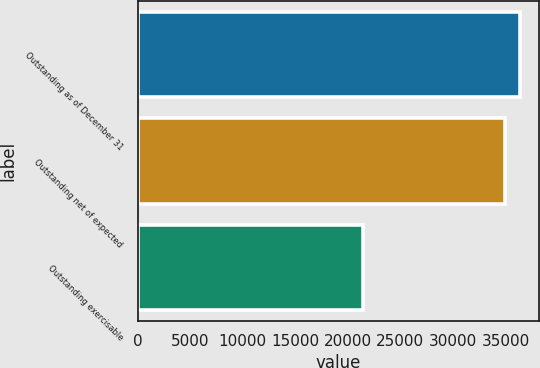Convert chart to OTSL. <chart><loc_0><loc_0><loc_500><loc_500><bar_chart><fcel>Outstanding as of December 31<fcel>Outstanding net of expected<fcel>Outstanding exercisable<nl><fcel>36350.6<fcel>34968<fcel>21470<nl></chart> 